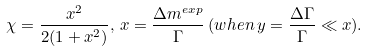Convert formula to latex. <formula><loc_0><loc_0><loc_500><loc_500>\chi = \frac { x ^ { 2 } } { 2 ( 1 + x ^ { 2 } ) } , \, x = \frac { \Delta m ^ { e x p } } { \Gamma } \, ( w h e n \, y = \frac { \Delta \Gamma } { \Gamma } \ll x ) .</formula> 